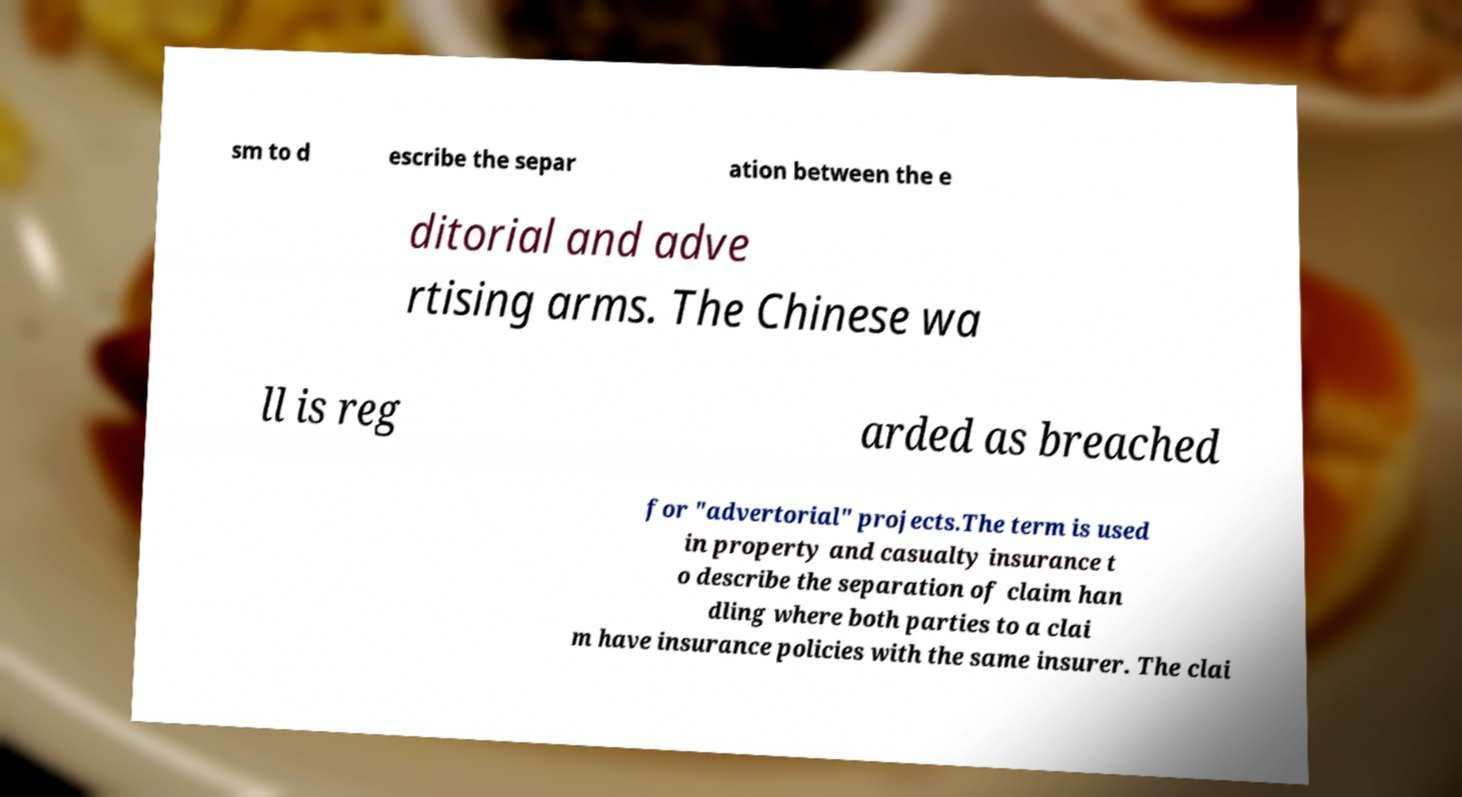I need the written content from this picture converted into text. Can you do that? sm to d escribe the separ ation between the e ditorial and adve rtising arms. The Chinese wa ll is reg arded as breached for "advertorial" projects.The term is used in property and casualty insurance t o describe the separation of claim han dling where both parties to a clai m have insurance policies with the same insurer. The clai 